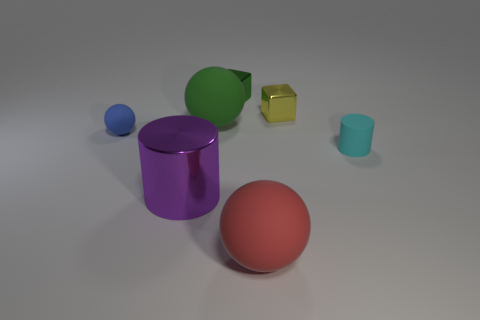Subtract all big balls. How many balls are left? 1 Add 1 tiny blue objects. How many objects exist? 8 Subtract 2 cubes. How many cubes are left? 0 Subtract all green balls. How many balls are left? 2 Subtract all balls. How many objects are left? 4 Subtract all yellow cylinders. Subtract all cyan spheres. How many cylinders are left? 2 Subtract 0 cyan cubes. How many objects are left? 7 Subtract all red cubes. How many cyan cylinders are left? 1 Subtract all big cyan shiny blocks. Subtract all matte things. How many objects are left? 3 Add 7 blue matte balls. How many blue matte balls are left? 8 